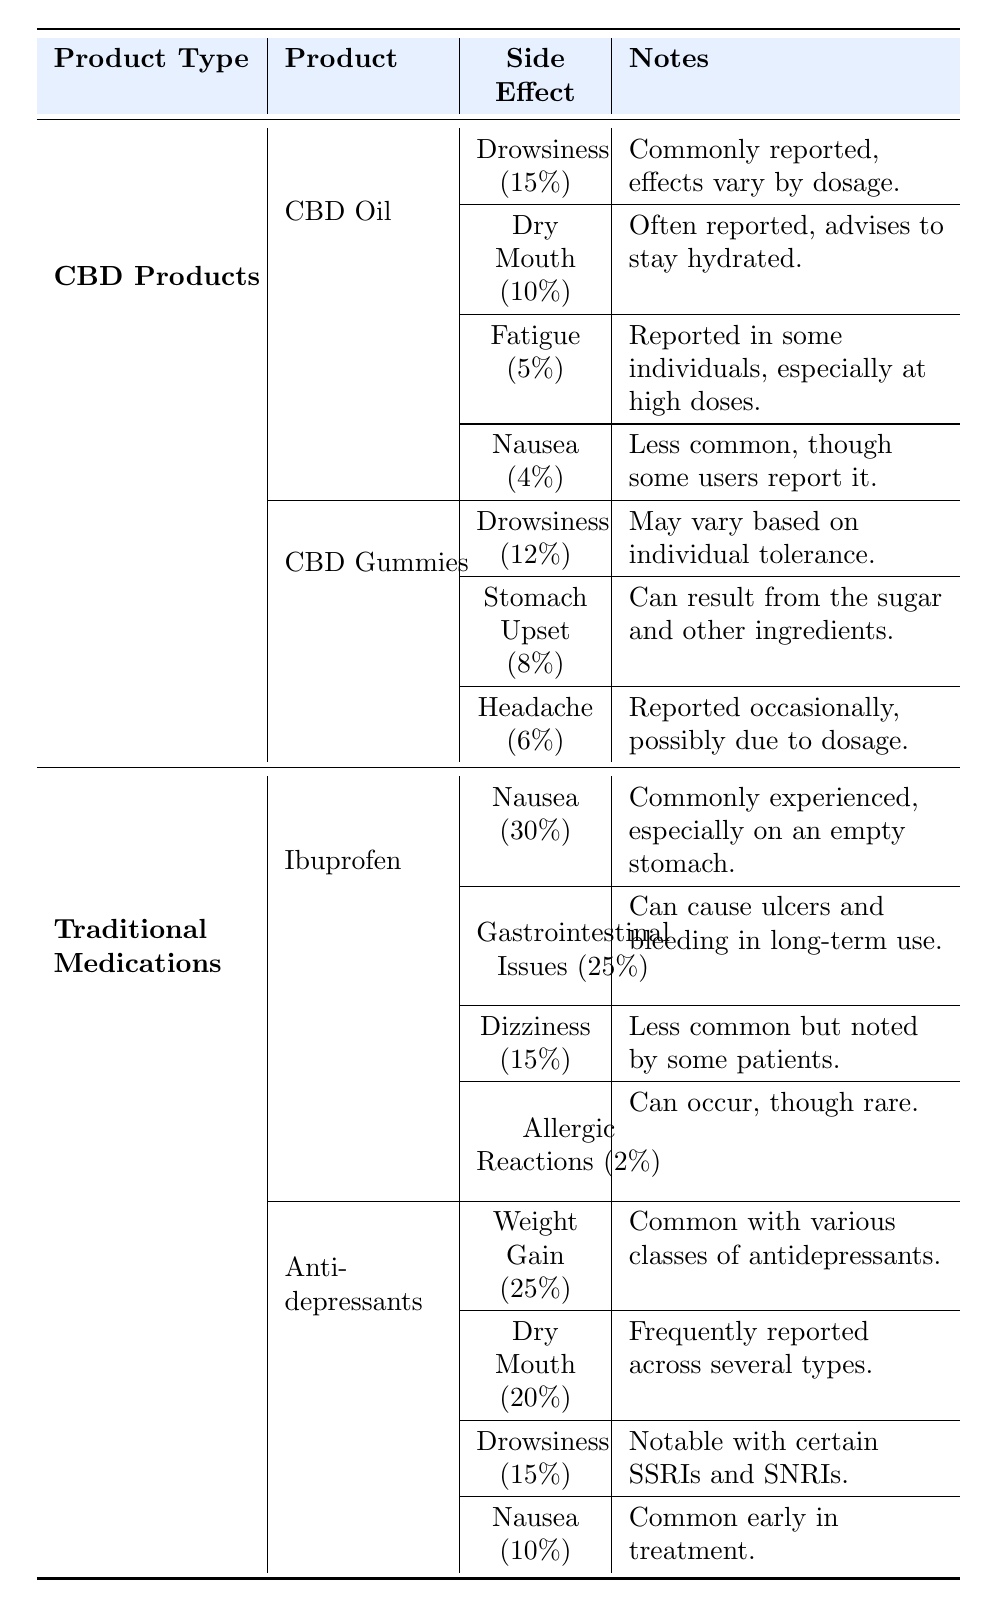What are the reported side effects of CBD Oil? The table lists four side effects for CBD Oil: Drowsiness (15%), Dry Mouth (10%), Fatigue (5%), and Nausea (4%).
Answer: Drowsiness, Dry Mouth, Fatigue, Nausea What percentage of people reported Drowsiness from CBD Gummies? According to the table, 12% of users reported Drowsiness as a side effect of CBD Gummies.
Answer: 12% Is Nausea a reported side effect for traditional medications? Yes, Nausea is reported as a side effect for both Ibuprofen (30%) and Antidepressants (10%).
Answer: Yes Which traditional medication has the highest reported side effect percentage for Nausea? The table shows that Ibuprofen has the highest percentage of Nausea reported at 30%, compared to Antidepressants at 10%.
Answer: Ibuprofen What is the average percentage of reported side effects for Drowsiness across CBD products? CBD Oil has 15% and CBD Gummies have 12% for Drowsiness. The average is (15 + 12) / 2 = 13.5%.
Answer: 13.5% How does the percentage of Dry Mouth in Traditional Medications compare to CBD Products? Dry Mouth is reported as 10% for CBD Oil, 20% for Antidepressants, and is not listed for Ibuprofen. The average for CBD Products is 10%. The average for Traditional Medications is (20) / 1 = 20%. Therefore, Traditional Medications report a higher average percentage of Dry Mouth.
Answer: Yes Do any reports indicate that CBD products have a reported side effect of Weight Gain? No, the table does not list Weight Gain as a reported side effect for any CBD product; it is only noted for Antidepressants.
Answer: No What is the total percentage of side effects reported for CBD Oil? The total percentage for side effects of CBD Oil is calculated by summing the percentages: 15% (Drowsiness) + 10% (Dry Mouth) + 5% (Fatigue) + 4% (Nausea) = 34%.
Answer: 34% Which product type shows Gastrointestinal Issues as a reported side effect? Gastrointestinal Issues is listed as a side effect for Ibuprofen in Traditional Medications with a percentage of 25%.
Answer: Ibuprofen 